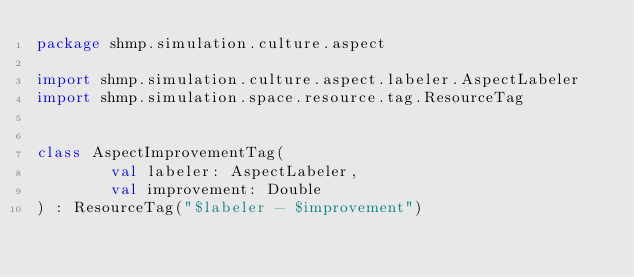<code> <loc_0><loc_0><loc_500><loc_500><_Kotlin_>package shmp.simulation.culture.aspect

import shmp.simulation.culture.aspect.labeler.AspectLabeler
import shmp.simulation.space.resource.tag.ResourceTag


class AspectImprovementTag(
        val labeler: AspectLabeler,
        val improvement: Double
) : ResourceTag("$labeler - $improvement")
</code> 